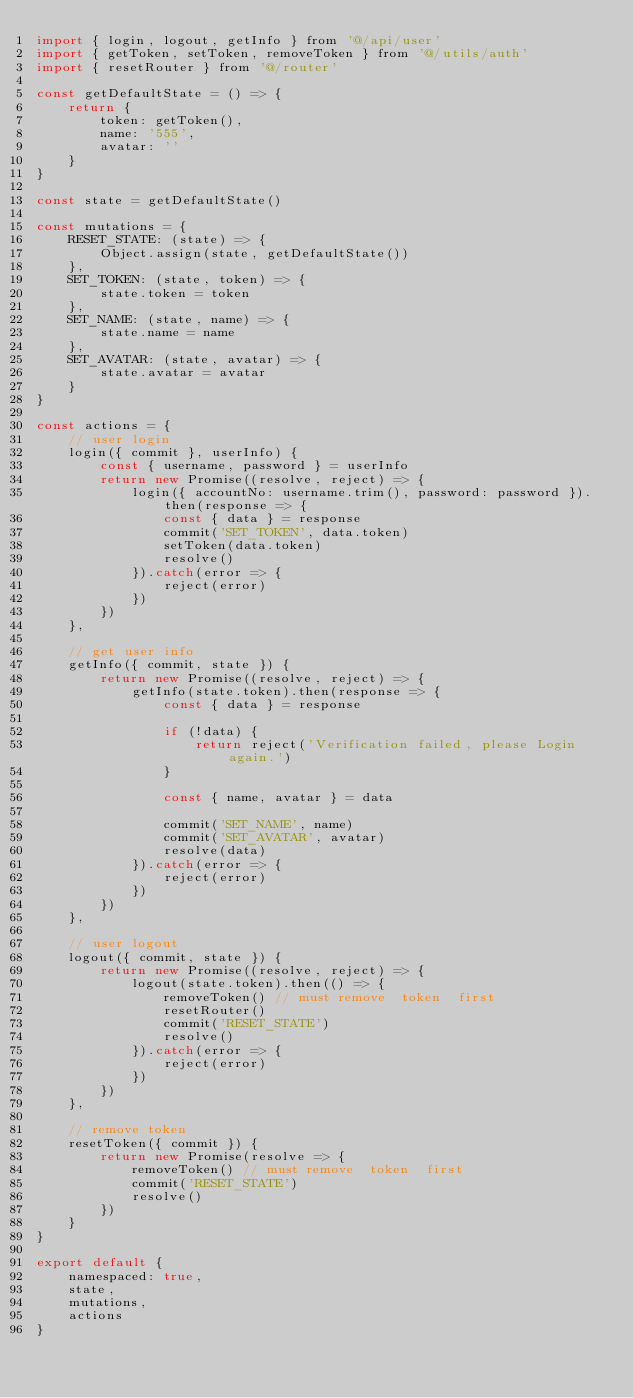<code> <loc_0><loc_0><loc_500><loc_500><_JavaScript_>import { login, logout, getInfo } from '@/api/user'
import { getToken, setToken, removeToken } from '@/utils/auth'
import { resetRouter } from '@/router'

const getDefaultState = () => {
    return {
        token: getToken(),
        name: '555',
        avatar: ''
    }
}

const state = getDefaultState()

const mutations = {
    RESET_STATE: (state) => {
        Object.assign(state, getDefaultState())
    },
    SET_TOKEN: (state, token) => {
        state.token = token
    },
    SET_NAME: (state, name) => {
        state.name = name
    },
    SET_AVATAR: (state, avatar) => {
        state.avatar = avatar
    }
}

const actions = {
    // user login
    login({ commit }, userInfo) {
        const { username, password } = userInfo
        return new Promise((resolve, reject) => {
            login({ accountNo: username.trim(), password: password }).then(response => {
                const { data } = response
                commit('SET_TOKEN', data.token)
                setToken(data.token)
                resolve()
            }).catch(error => {
                reject(error)
            })
        })
    },

    // get user info
    getInfo({ commit, state }) {
        return new Promise((resolve, reject) => {
            getInfo(state.token).then(response => {
                const { data } = response

                if (!data) {
                    return reject('Verification failed, please Login again.')
                }

                const { name, avatar } = data

                commit('SET_NAME', name)
                commit('SET_AVATAR', avatar)
                resolve(data)
            }).catch(error => {
                reject(error)
            })
        })
    },

    // user logout
    logout({ commit, state }) {
        return new Promise((resolve, reject) => {
            logout(state.token).then(() => {
                removeToken() // must remove  token  first
                resetRouter()
                commit('RESET_STATE')
                resolve()
            }).catch(error => {
                reject(error)
            })
        })
    },

    // remove token
    resetToken({ commit }) {
        return new Promise(resolve => {
            removeToken() // must remove  token  first
            commit('RESET_STATE')
            resolve()
        })
    }
}

export default {
    namespaced: true,
    state,
    mutations,
    actions
}</code> 